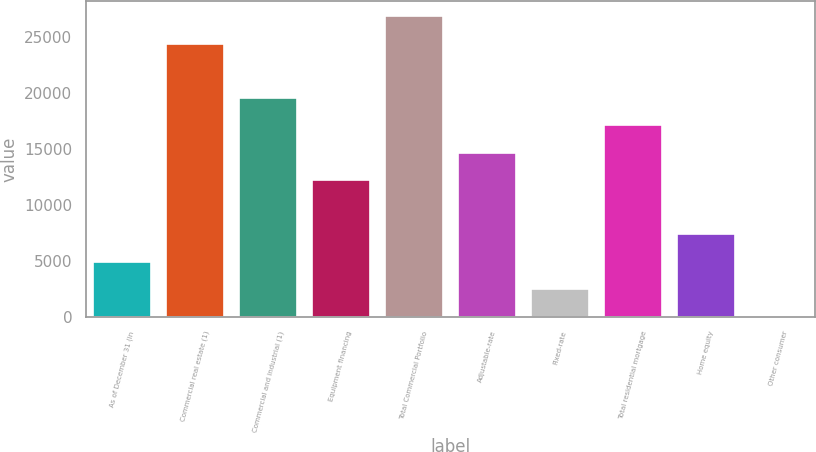<chart> <loc_0><loc_0><loc_500><loc_500><bar_chart><fcel>As of December 31 (in<fcel>Commercial real estate (1)<fcel>Commercial and industrial (1)<fcel>Equipment financing<fcel>Total Commercial Portfolio<fcel>Adjustable-rate<fcel>Fixed-rate<fcel>Total residential mortgage<fcel>Home equity<fcel>Other consumer<nl><fcel>4935.9<fcel>24390.3<fcel>19526.7<fcel>12231.3<fcel>26822.1<fcel>14663.1<fcel>2504.1<fcel>17094.9<fcel>7367.7<fcel>72.3<nl></chart> 